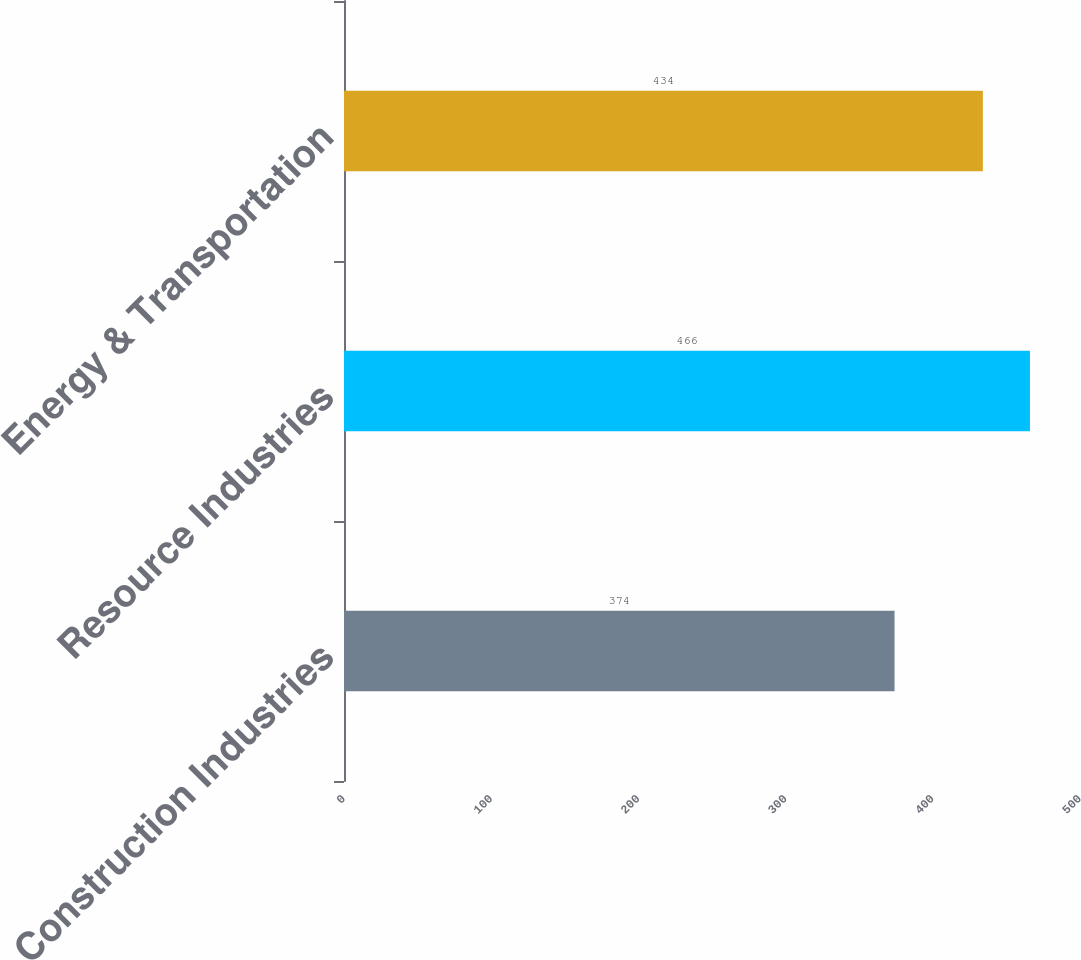<chart> <loc_0><loc_0><loc_500><loc_500><bar_chart><fcel>Construction Industries<fcel>Resource Industries<fcel>Energy & Transportation<nl><fcel>374<fcel>466<fcel>434<nl></chart> 